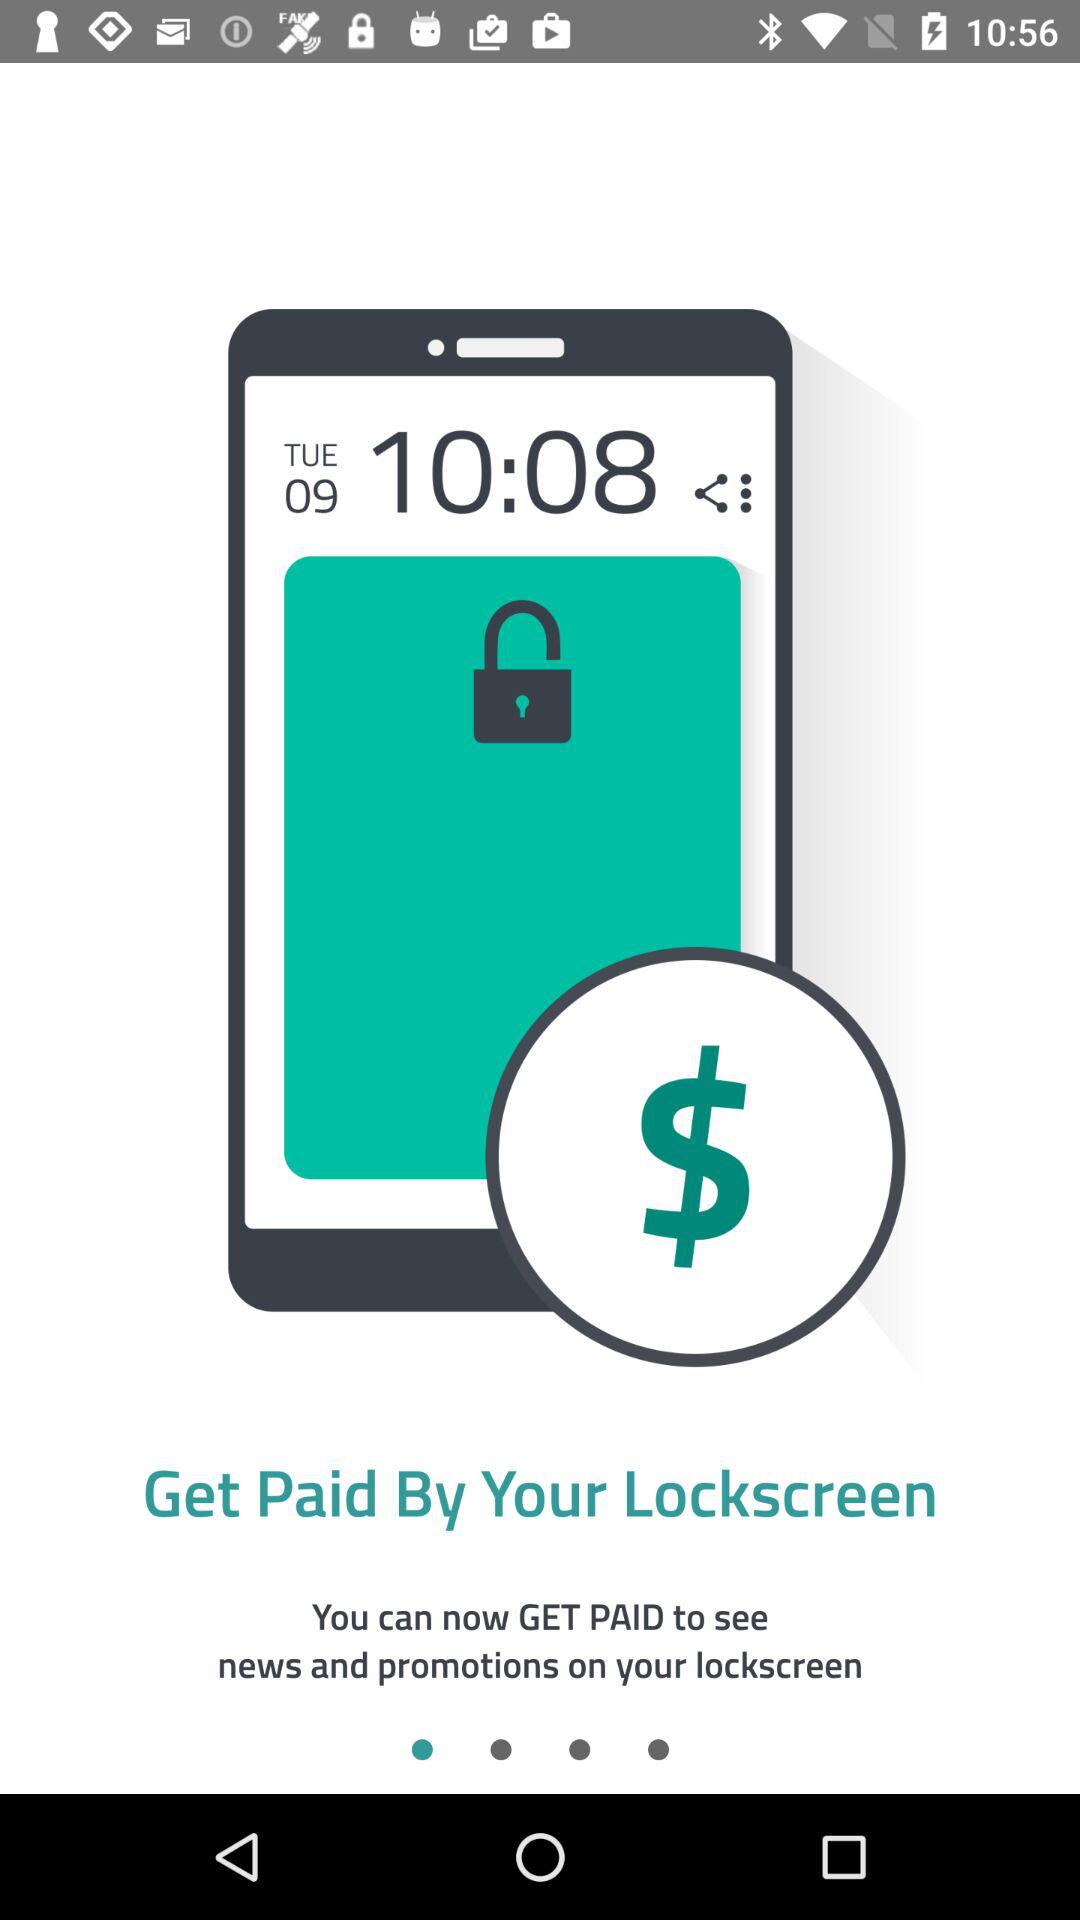How many pages are there?
When the provided information is insufficient, respond with <no answer>. <no answer> 